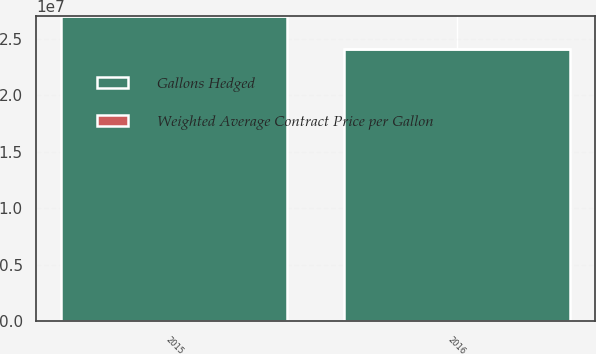<chart> <loc_0><loc_0><loc_500><loc_500><stacked_bar_chart><ecel><fcel>2015<fcel>2016<nl><fcel>Gallons Hedged<fcel>2.7e+07<fcel>2.412e+07<nl><fcel>Weighted Average Contract Price per Gallon<fcel>3.76<fcel>3.64<nl></chart> 